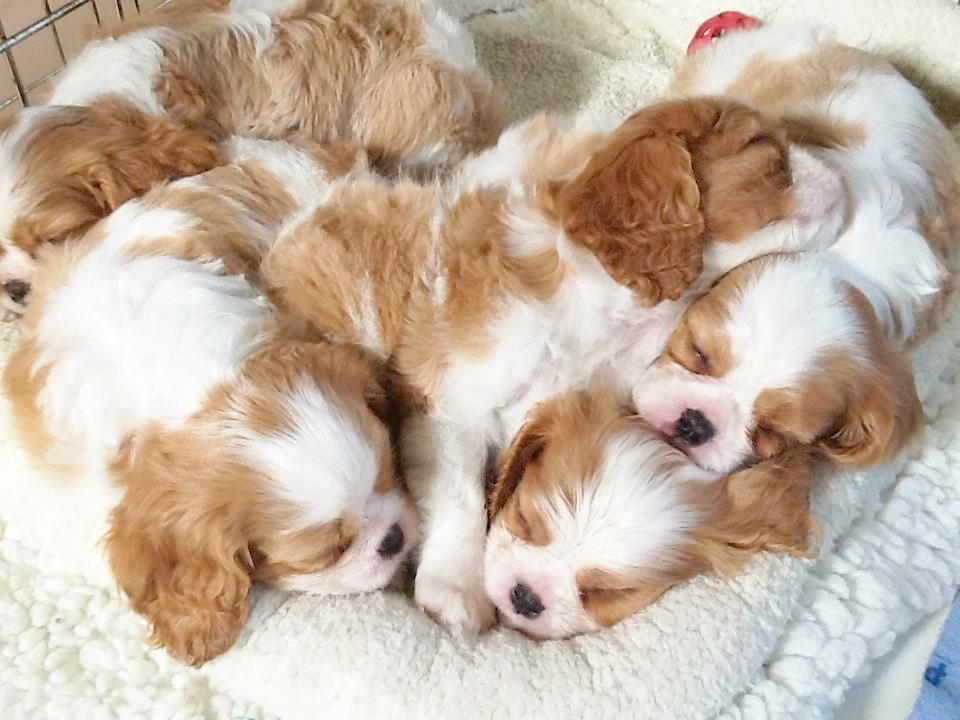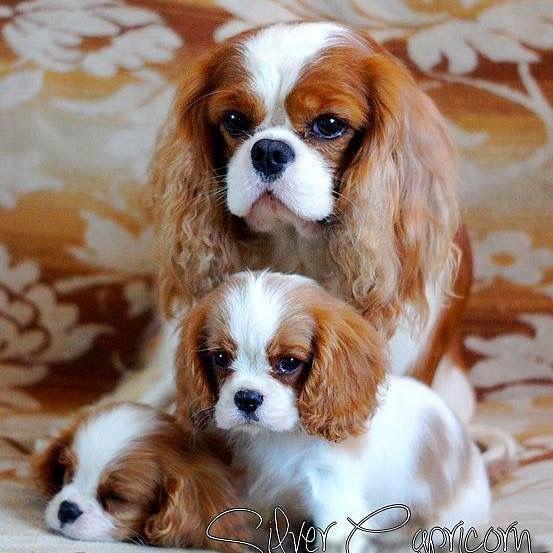The first image is the image on the left, the second image is the image on the right. Examine the images to the left and right. Is the description "In one of the image there are puppies near an adult dog." accurate? Answer yes or no. Yes. The first image is the image on the left, the second image is the image on the right. Analyze the images presented: Is the assertion "The left image has no more than one dog laying down." valid? Answer yes or no. No. 